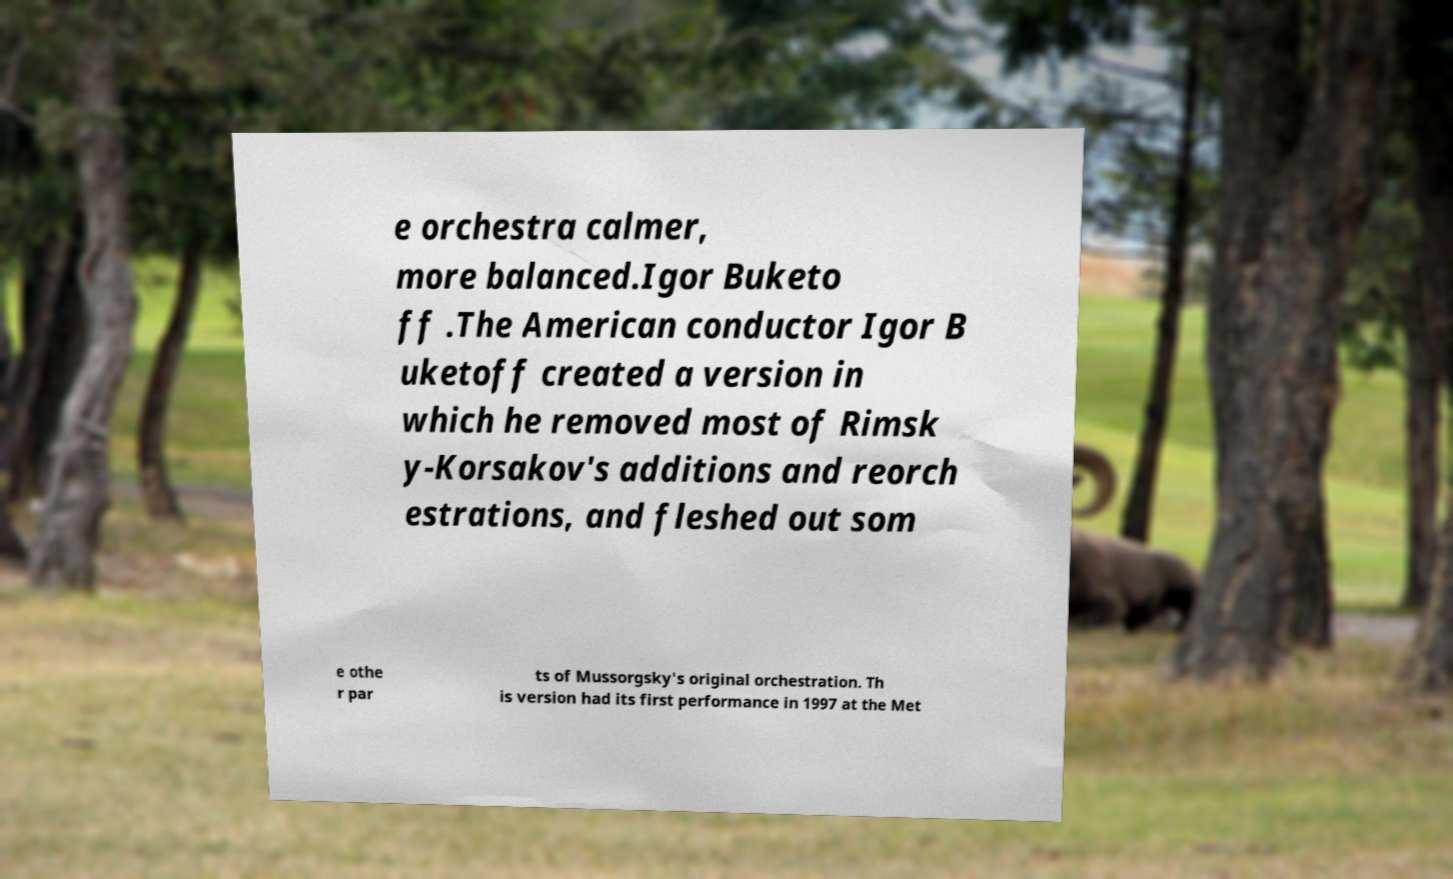What messages or text are displayed in this image? I need them in a readable, typed format. e orchestra calmer, more balanced.Igor Buketo ff .The American conductor Igor B uketoff created a version in which he removed most of Rimsk y-Korsakov's additions and reorch estrations, and fleshed out som e othe r par ts of Mussorgsky's original orchestration. Th is version had its first performance in 1997 at the Met 